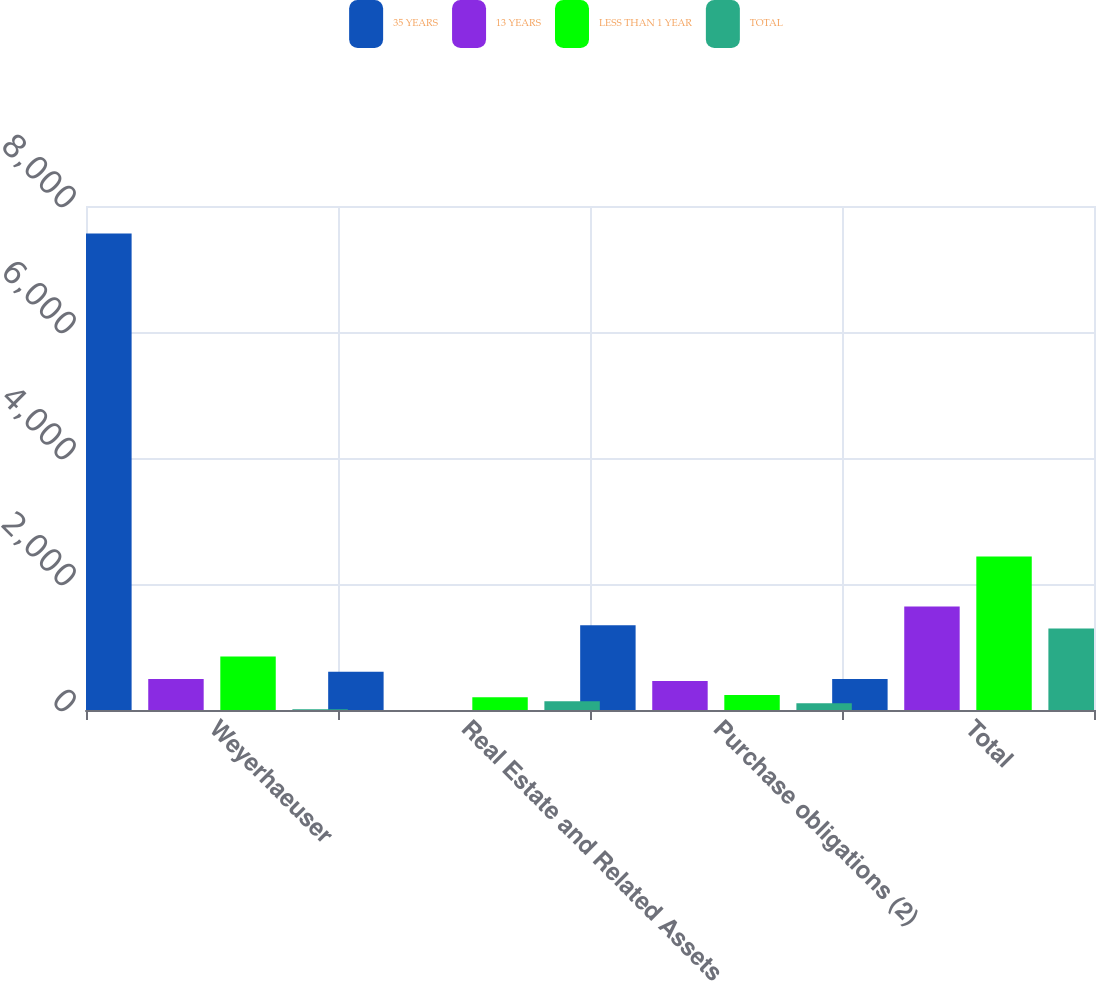Convert chart to OTSL. <chart><loc_0><loc_0><loc_500><loc_500><stacked_bar_chart><ecel><fcel>Weyerhaeuser<fcel>Real Estate and Related Assets<fcel>Purchase obligations (2)<fcel>Total<nl><fcel>35 YEARS<fcel>7565<fcel>606<fcel>1345<fcel>494<nl><fcel>13 YEARS<fcel>494<fcel>1<fcel>459<fcel>1643<nl><fcel>LESS THAN 1 YEAR<fcel>851<fcel>201<fcel>238<fcel>2436<nl><fcel>TOTAL<fcel>11<fcel>140<fcel>108<fcel>1294<nl></chart> 